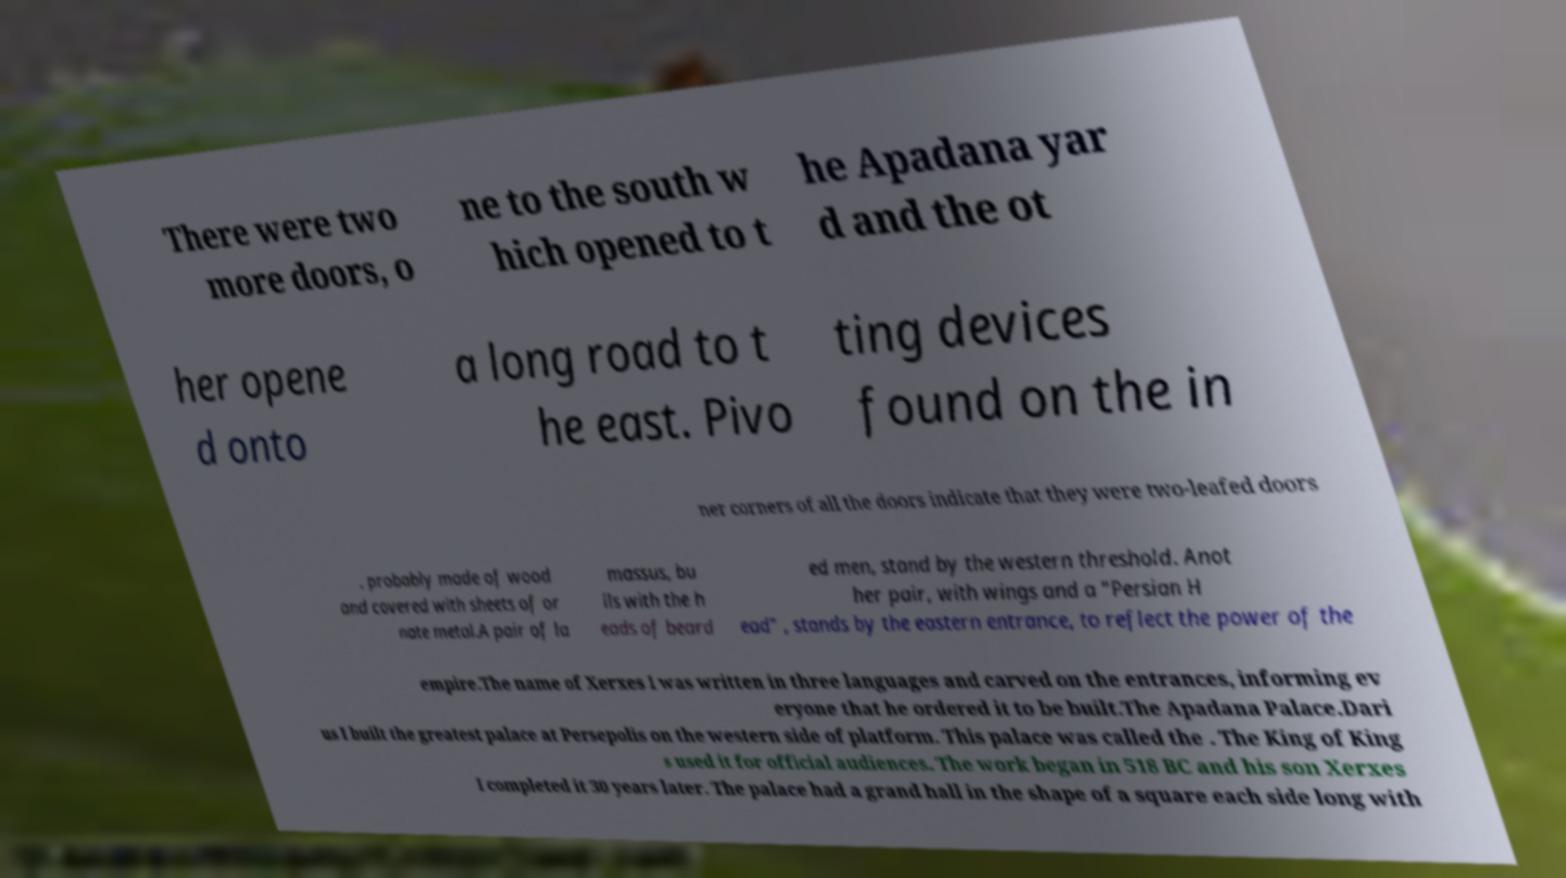Could you assist in decoding the text presented in this image and type it out clearly? There were two more doors, o ne to the south w hich opened to t he Apadana yar d and the ot her opene d onto a long road to t he east. Pivo ting devices found on the in ner corners of all the doors indicate that they were two-leafed doors , probably made of wood and covered with sheets of or nate metal.A pair of la massus, bu lls with the h eads of beard ed men, stand by the western threshold. Anot her pair, with wings and a "Persian H ead" , stands by the eastern entrance, to reflect the power of the empire.The name of Xerxes I was written in three languages and carved on the entrances, informing ev eryone that he ordered it to be built.The Apadana Palace.Dari us I built the greatest palace at Persepolis on the western side of platform. This palace was called the . The King of King s used it for official audiences. The work began in 518 BC and his son Xerxes I completed it 30 years later. The palace had a grand hall in the shape of a square each side long with 